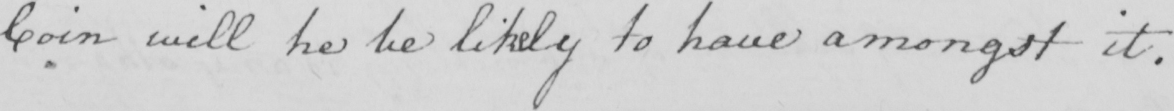Can you tell me what this handwritten text says? Coin will he be likely to have amongst it . 